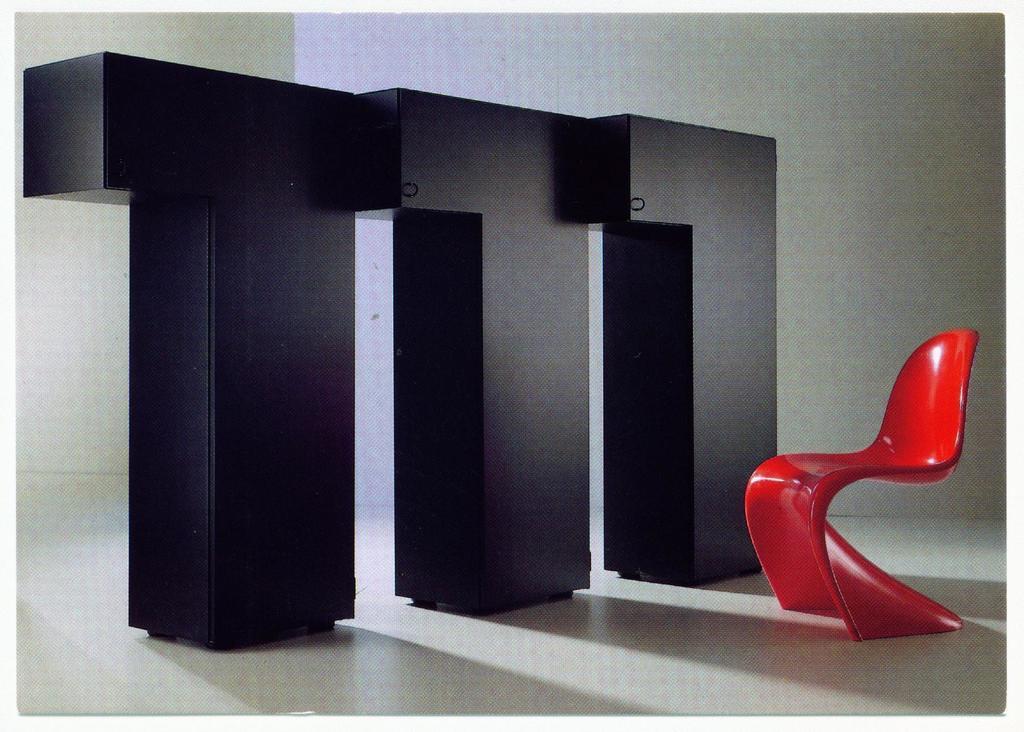How would you summarize this image in a sentence or two? This image is taken indoors. At the bottom of the image there is a floor. On the right side of the image there is a chair. In the background there is a wall. In the middle of the image there are three wooden blocks. 